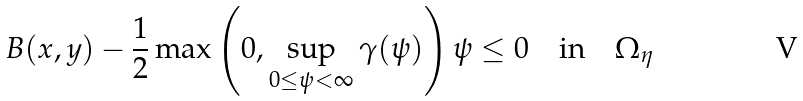<formula> <loc_0><loc_0><loc_500><loc_500>B ( x , y ) - \frac { 1 } { 2 } \max \left ( 0 , \sup _ { 0 \leq \psi < \infty } \gamma ( \psi ) \right ) \psi \leq 0 \quad \text {in} \quad \Omega _ { \eta }</formula> 